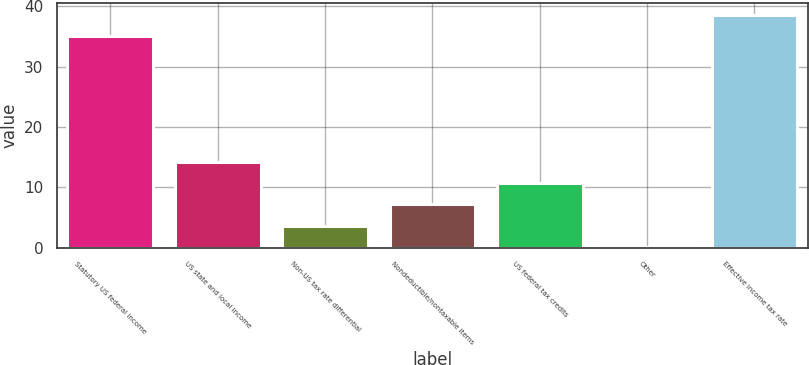Convert chart to OTSL. <chart><loc_0><loc_0><loc_500><loc_500><bar_chart><fcel>Statutory US federal income<fcel>US state and local income<fcel>Non-US tax rate differential<fcel>Nondeductible/nontaxable items<fcel>US federal tax credits<fcel>Other<fcel>Effective income tax rate<nl><fcel>35<fcel>14.26<fcel>3.64<fcel>7.18<fcel>10.72<fcel>0.1<fcel>38.54<nl></chart> 